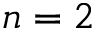Convert formula to latex. <formula><loc_0><loc_0><loc_500><loc_500>n = 2</formula> 